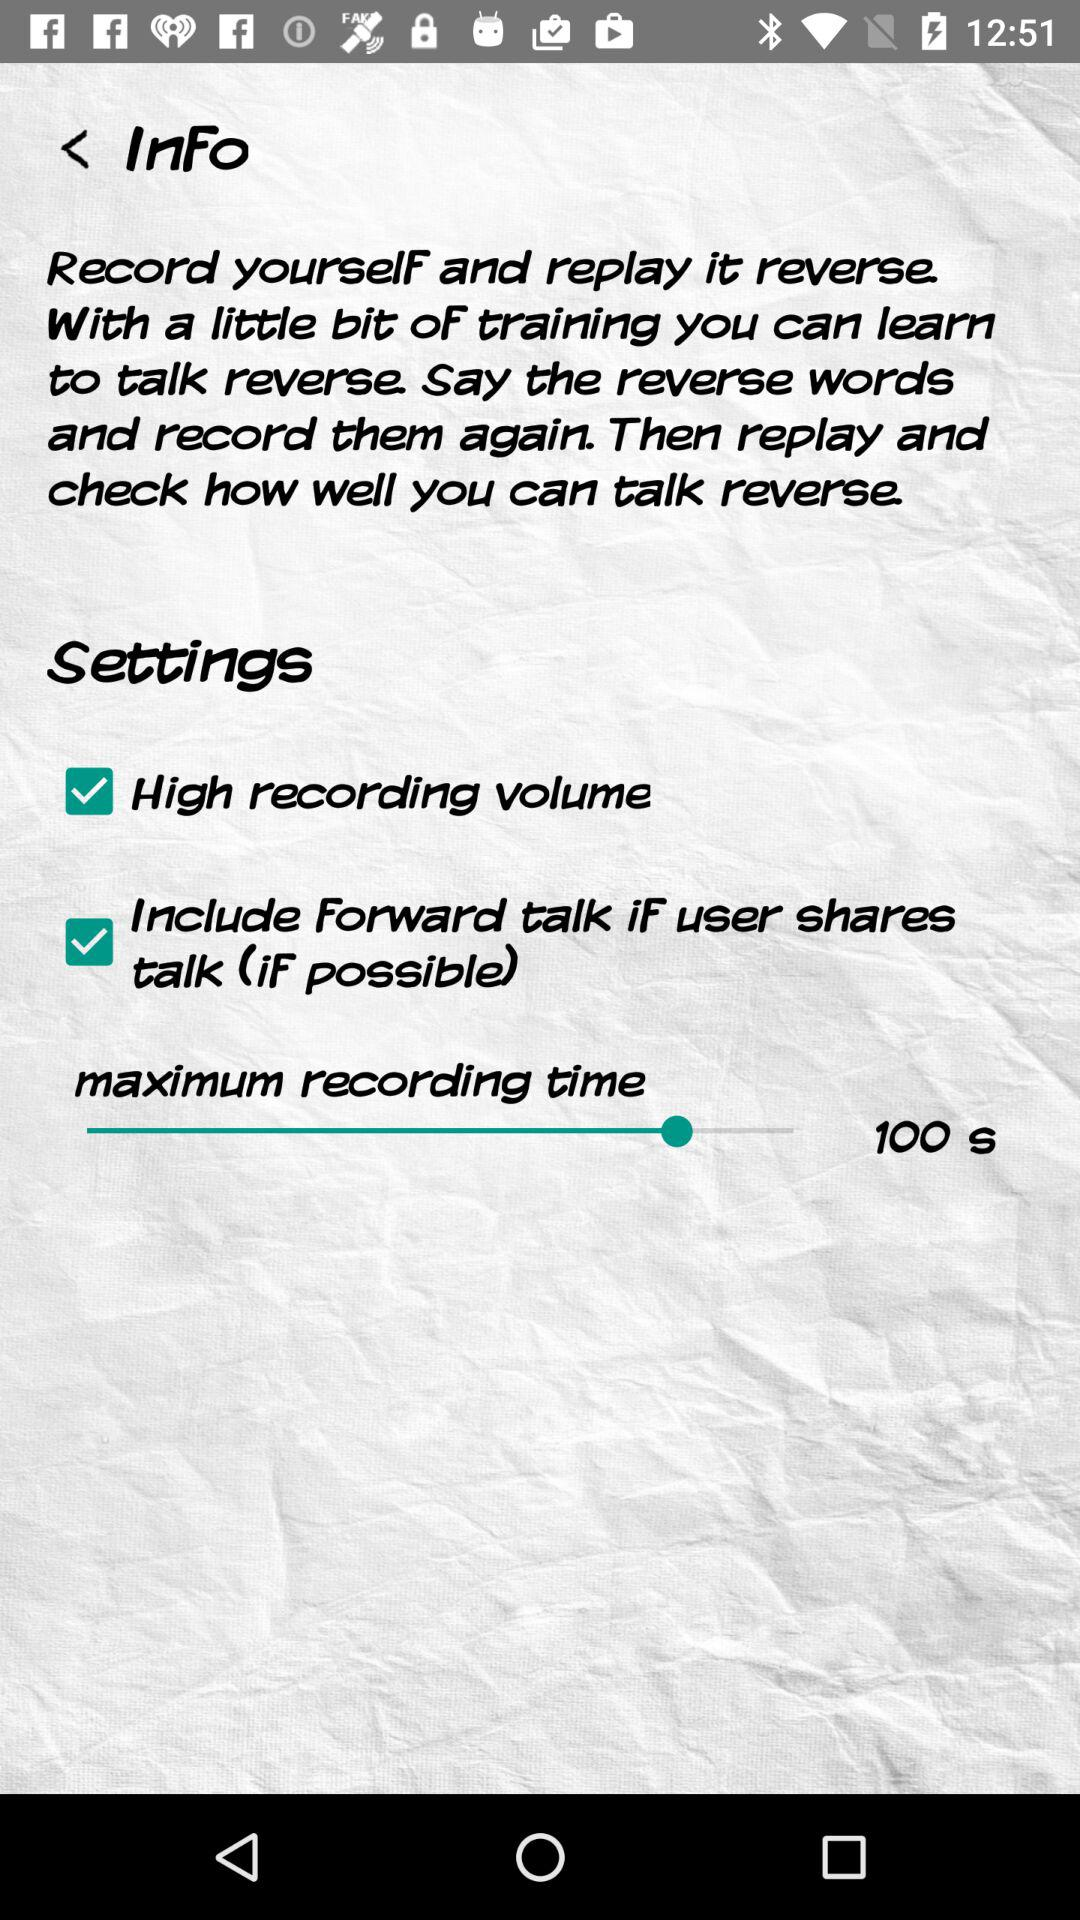What is checked in the settings? There are "High recording volume" and "Include Forward talk iF user shares talk (iF possible)" checked in the settings. 